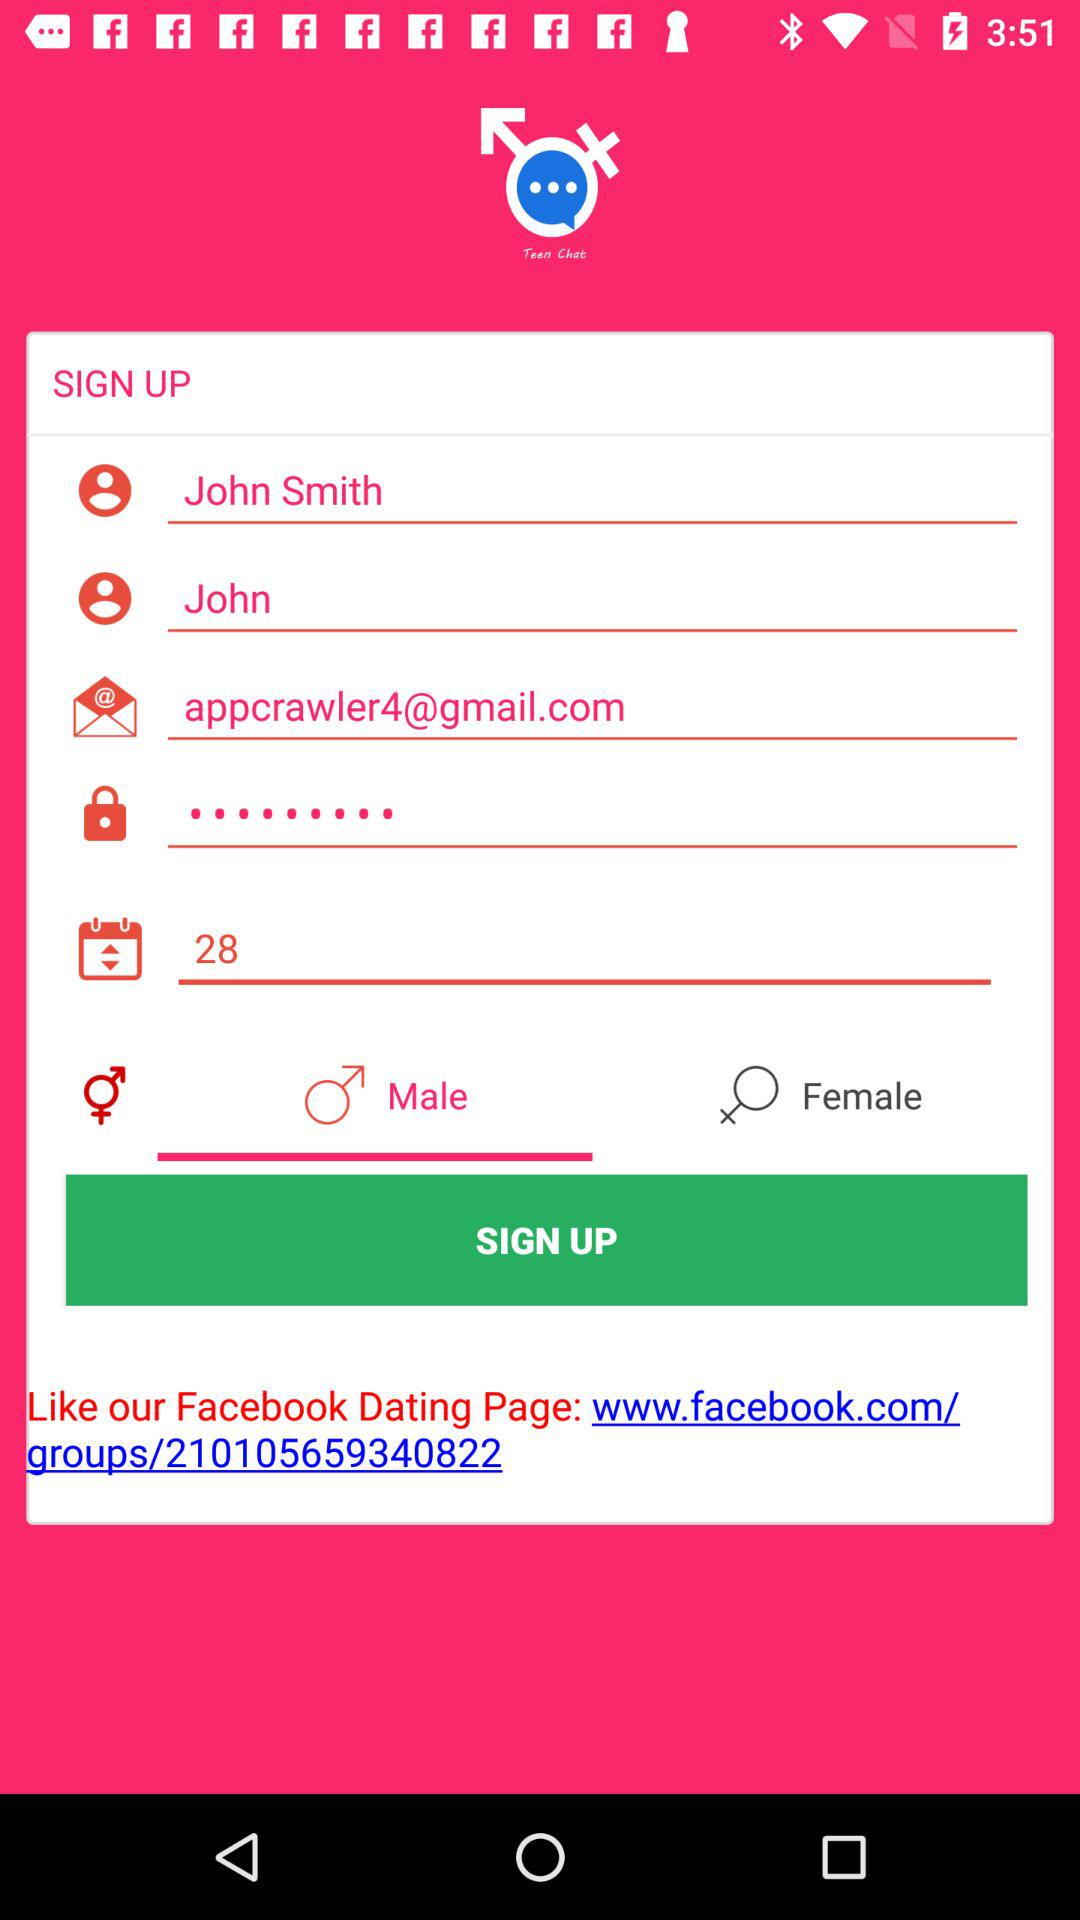What is the name of the user? The name of the user is John Smith. 